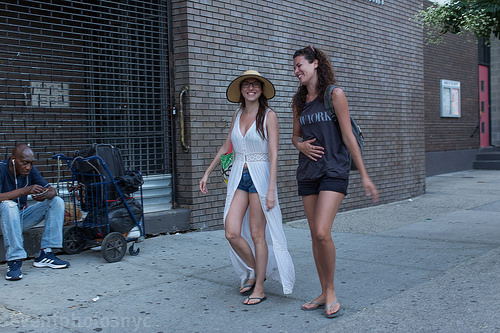<image>
Is there a hat on the woman? No. The hat is not positioned on the woman. They may be near each other, but the hat is not supported by or resting on top of the woman. Where is the tree in relation to the sign? Is it above the sign? Yes. The tree is positioned above the sign in the vertical space, higher up in the scene. 